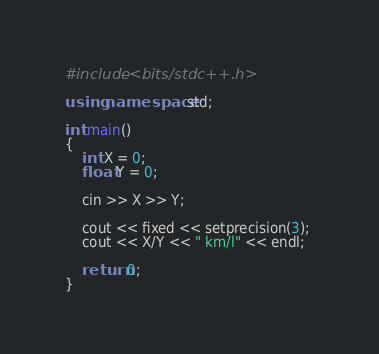Convert code to text. <code><loc_0><loc_0><loc_500><loc_500><_C++_>#include <bits/stdc++.h>

using namespace std;

int main()
{
	int X = 0;
	float Y = 0;
	
	cin >> X >> Y;
	
	cout << fixed << setprecision(3); 
	cout << X/Y << " km/l" << endl;
	
	return 0;
}</code> 